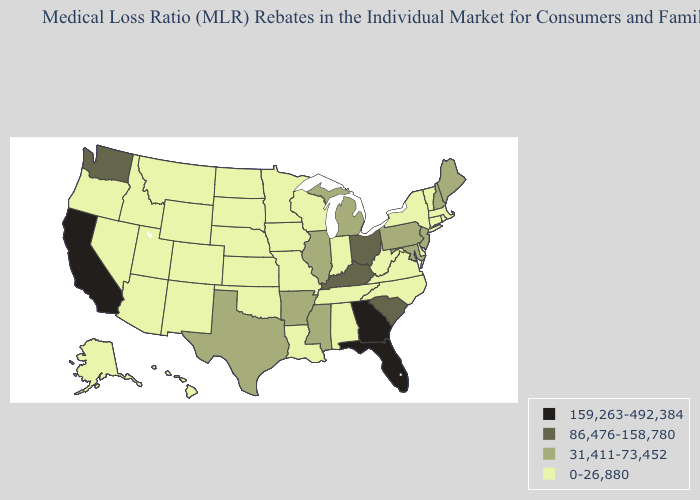Which states have the lowest value in the USA?
Short answer required. Alabama, Alaska, Arizona, Colorado, Connecticut, Delaware, Hawaii, Idaho, Indiana, Iowa, Kansas, Louisiana, Massachusetts, Minnesota, Missouri, Montana, Nebraska, Nevada, New Mexico, New York, North Carolina, North Dakota, Oklahoma, Oregon, Rhode Island, South Dakota, Tennessee, Utah, Vermont, Virginia, West Virginia, Wisconsin, Wyoming. Name the states that have a value in the range 31,411-73,452?
Concise answer only. Arkansas, Illinois, Maine, Maryland, Michigan, Mississippi, New Hampshire, New Jersey, Pennsylvania, Texas. Does Florida have the highest value in the USA?
Concise answer only. Yes. What is the highest value in the USA?
Quick response, please. 159,263-492,384. What is the lowest value in the Northeast?
Concise answer only. 0-26,880. Among the states that border North Carolina , does Virginia have the highest value?
Concise answer only. No. What is the value of Indiana?
Give a very brief answer. 0-26,880. What is the value of South Carolina?
Concise answer only. 86,476-158,780. What is the value of Maine?
Quick response, please. 31,411-73,452. Does New Jersey have a higher value than Idaho?
Answer briefly. Yes. What is the value of West Virginia?
Keep it brief. 0-26,880. Is the legend a continuous bar?
Answer briefly. No. What is the highest value in states that border California?
Answer briefly. 0-26,880. Name the states that have a value in the range 159,263-492,384?
Concise answer only. California, Florida, Georgia. Name the states that have a value in the range 159,263-492,384?
Give a very brief answer. California, Florida, Georgia. 